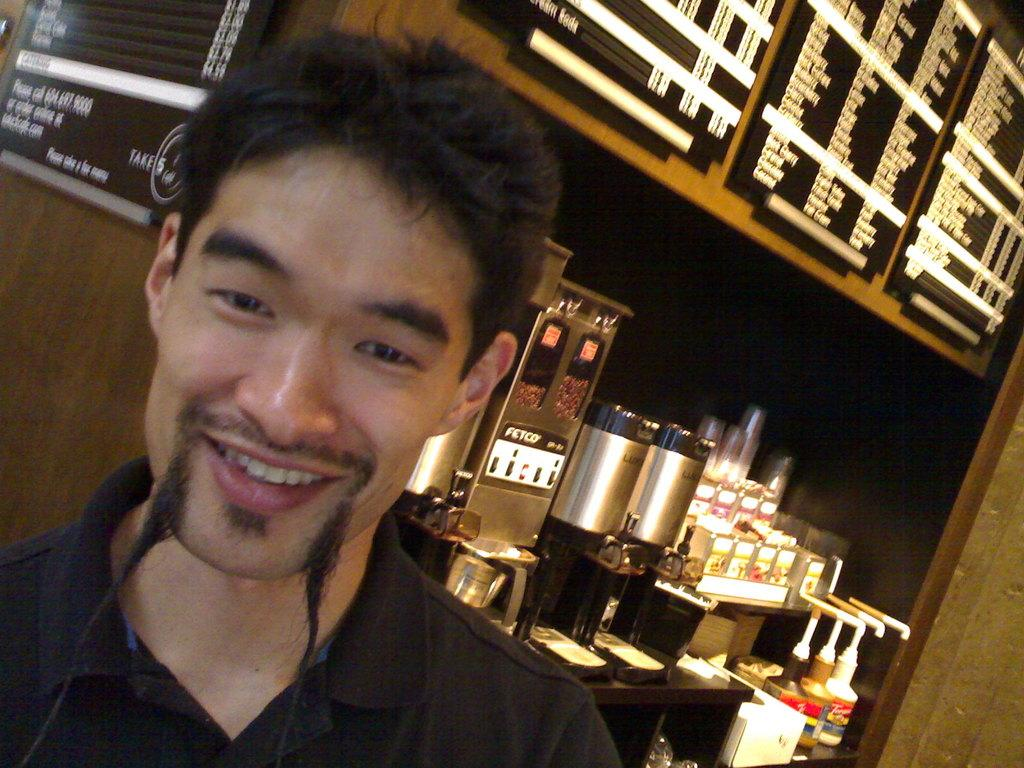Who is present in the image? There is a man in the image. What is the man's facial expression? The man is smiling. What can be seen on the wall in the background? There are boards attached to the wall in the background. What type of objects are present in the background? There are machines, glasses, bottles, and other items in the racks in the background. What type of chain is being used to hold the quilt in the image? There is no chain or quilt present in the image. How many yaks are visible in the image? There are no yaks visible in the image. 